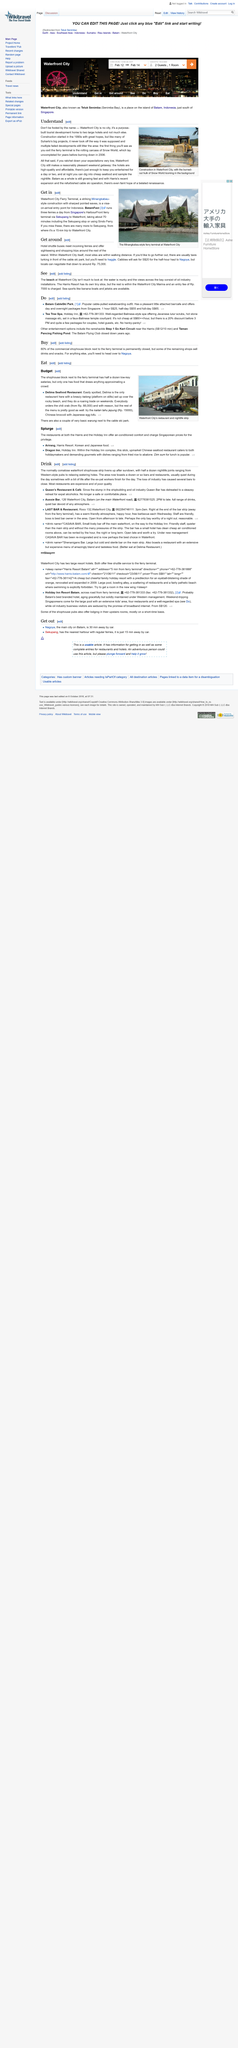Specify some key components in this picture. BatamFast operates three ferries daily, transporting passengers and cargo to and from the island. The image on the top was taken at Waterfront City. Waterfront City at night offers an array of activities for visitors to enjoy. From savoring delicious and affordable seafood to immersing oneself in the vibrant nightlife scene, there is truly something for everyone to enjoy. The Cable Ski Park is adjacent to a collection of humble warungs, offering limited culinary options for visitors. Snow World, an amusement park that had been abandoned for several years, finally burned down in 2006. 